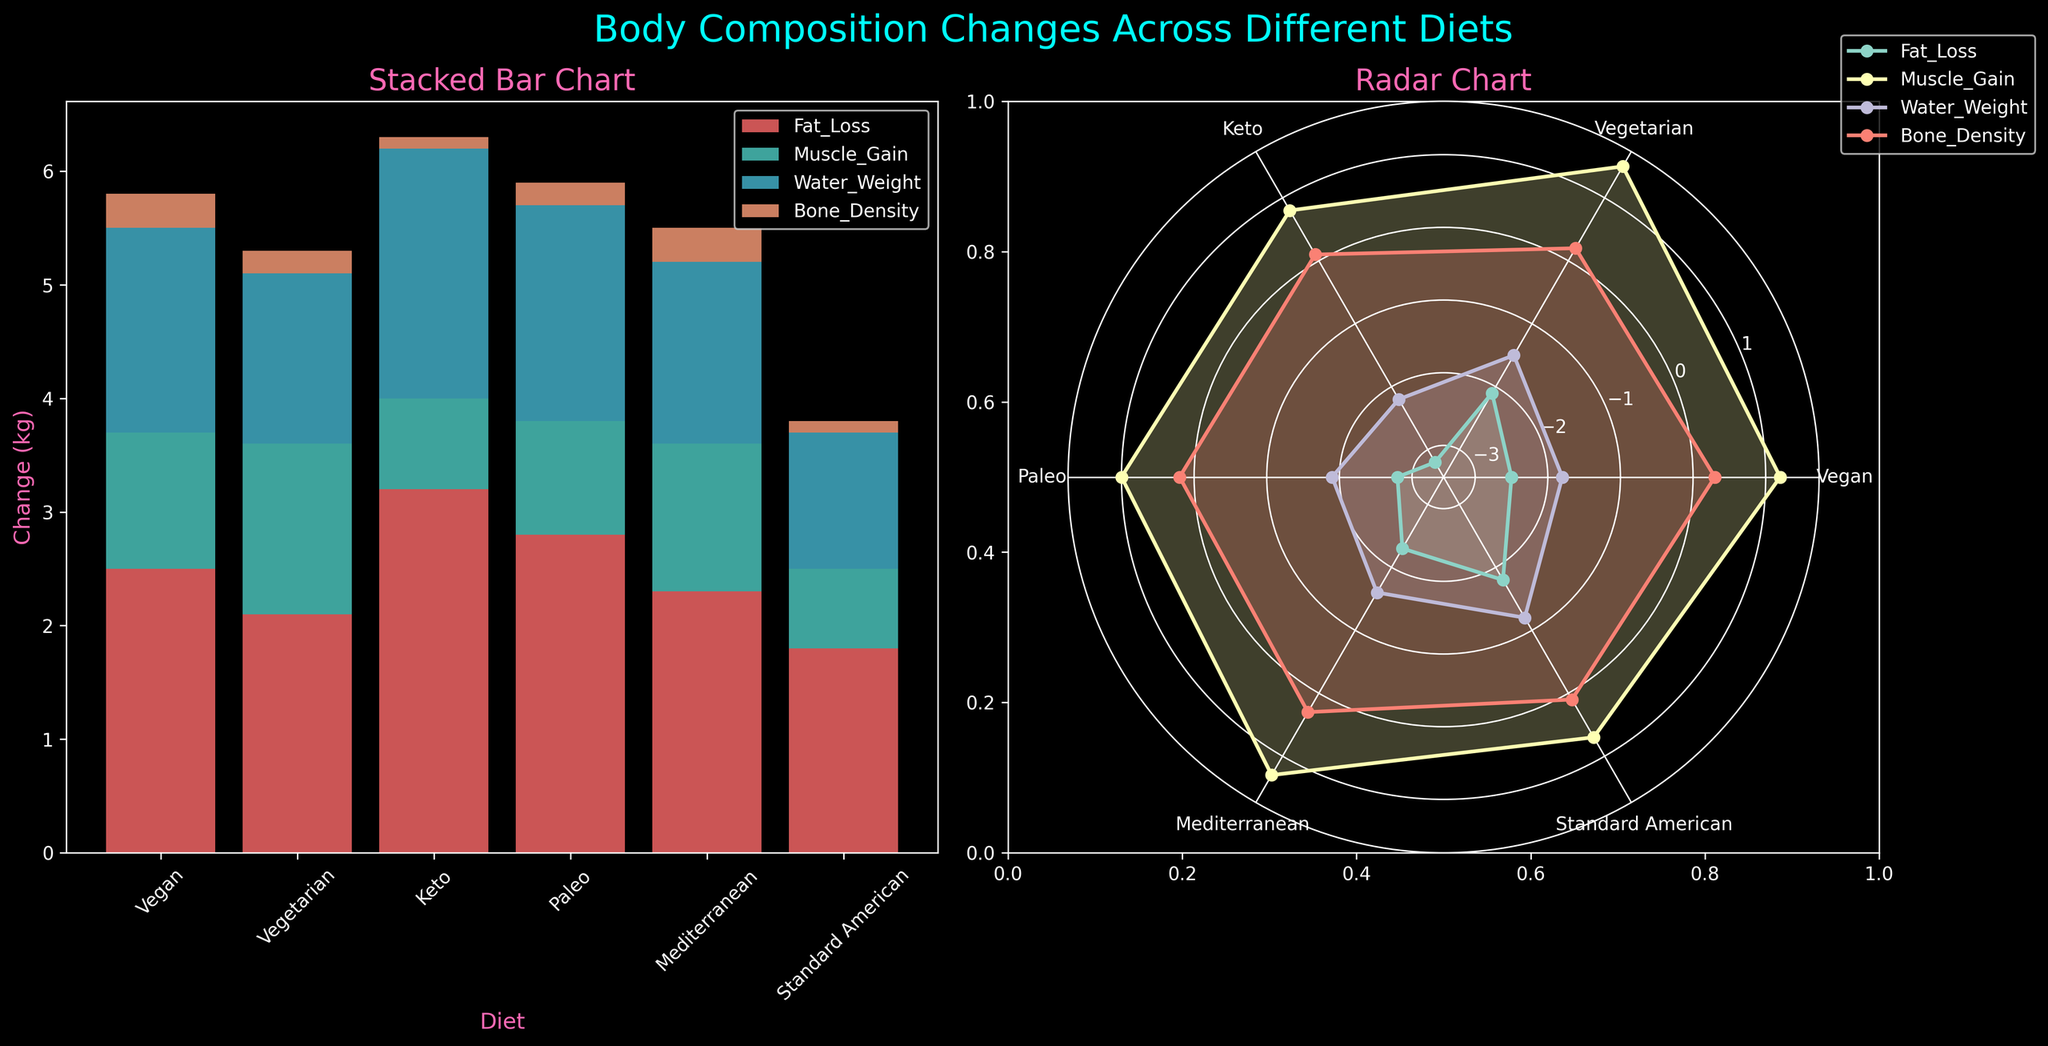What's the title of the figure? The title of the figure is located at the top center of the image and provides an overview of what the plot represents.
Answer: Body Composition Changes Across Different Diets Which diet group shows the highest fat loss in the stacked bar chart? The vegan diet group has the bottom segment of the bars in the stacked bar chart representative of fat loss, and it shows the most significant decrease compared to other groups in terms of length.
Answer: Keto How many diet groups are compared in the radar chart? In the radar chart, each diet group is marked along the circumference of the circular chart. There are six labels corresponding to different diet groups.
Answer: 6 Which diet groups exhibit muscle gain greater than 1 kg? In the stacked bar chart, the segments representing muscle gain are color-coded. By observing the height of each segment, it's clear that the Vegan, Vegetarian, and Mediterranean groups have muscle gains greater than 1 kg.
Answer: Vegan, Vegetarian, Mediterranean What's the total change in body composition for the Mediterranean diet group? To calculate the total change, sum up the values for each segment in the Mediterranean diet group from the stacked bar chart (Fat_Loss + Muscle_Gain + Water_Weight + Bone_Density).
Answer: -2.3 + 1.3 - 1.6 + 0.3 = -2.3 How do the changes in fat loss for the Paleo and Standard American diets compare? To compare, observe the lengths of the fat loss segments in the stacked bar chart. The Paleo diet group shows a larger segment compared to the Standard American diet group.
Answer: Paleo > Standard American What is the sum of water weight changes for all diet groups? Sum the values of the water weight segments across all the diet groups from the stacked bar chart. (-1.8) + (-1.5) + (-2.2) + (-1.9) + (-1.6) + (-1.2) = -10.2
Answer: -10.2 Which diet group has the smallest change in bone density? By looking at the bone density segments in the stacked bar chart, the Keto and Standard American groups have the smallest segments indicating a change in bone density.
Answer: Keto, Standard American What's the average muscle gain across all diets? Add the muscle gain values for all diet groups and divide by the number of diet groups. (1.2 + 1.5 + 0.8 + 1.0 + 1.3 + 0.7) / 6 = 6.5 / 6
Answer: 1.08 